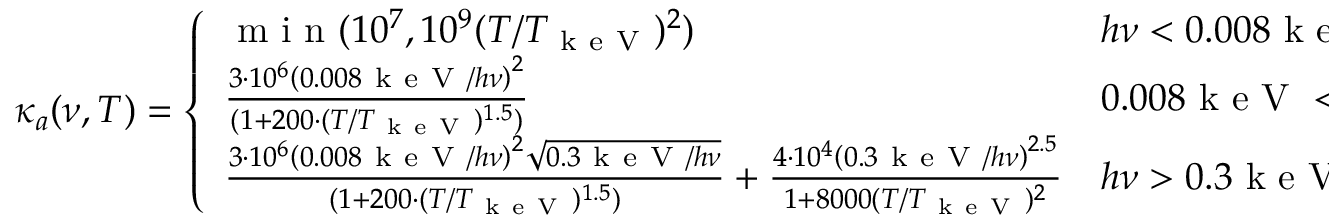<formula> <loc_0><loc_0><loc_500><loc_500>\kappa _ { a } ( \nu , T ) = \left \{ \begin{array} { l l } { m i n ( 1 0 ^ { 7 } , 1 0 ^ { 9 } ( T / T _ { k e V } ) ^ { 2 } ) } & { h \nu < 0 . 0 0 8 k e V } \\ { \frac { 3 \cdot 1 0 ^ { 6 } \left ( 0 . 0 0 8 k e V / h \nu \right ) ^ { 2 } } { ( 1 + 2 0 0 \cdot ( T / T _ { k e V } ) ^ { 1 . 5 } ) } } & { 0 . 0 0 8 k e V < h \nu < 0 . 3 k e V } \\ { \frac { 3 \cdot 1 0 ^ { 6 } \left ( 0 . 0 0 8 k e V / h \nu \right ) ^ { 2 } \sqrt { 0 . 3 k e V / h \nu } } { ( 1 + 2 0 0 \cdot ( T / T _ { k e V } ) ^ { 1 . 5 } ) } + \frac { 4 \cdot 1 0 ^ { 4 } \left ( 0 . 3 k e V / h \nu \right ) ^ { 2 . 5 } } { 1 + 8 0 0 0 ( T / T _ { k e V } ) ^ { 2 } } } & { h \nu > 0 . 3 k e V . } \end{array}</formula> 